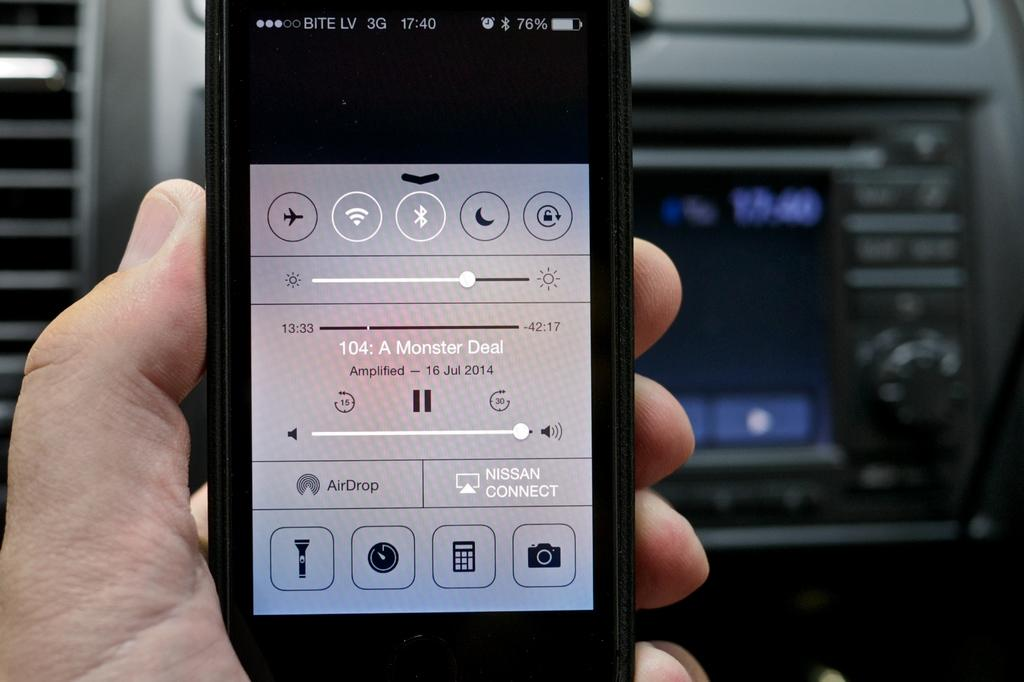Provide a one-sentence caption for the provided image. A phone has an audio file on the screen titled A Monster Deal. 